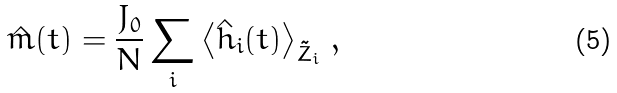Convert formula to latex. <formula><loc_0><loc_0><loc_500><loc_500>\hat { m } ( t ) = \frac { J _ { 0 } } { N } \sum _ { i } \left \langle \hat { h } _ { i } ( t ) \right \rangle _ { \tilde { Z } _ { i } } \, ,</formula> 